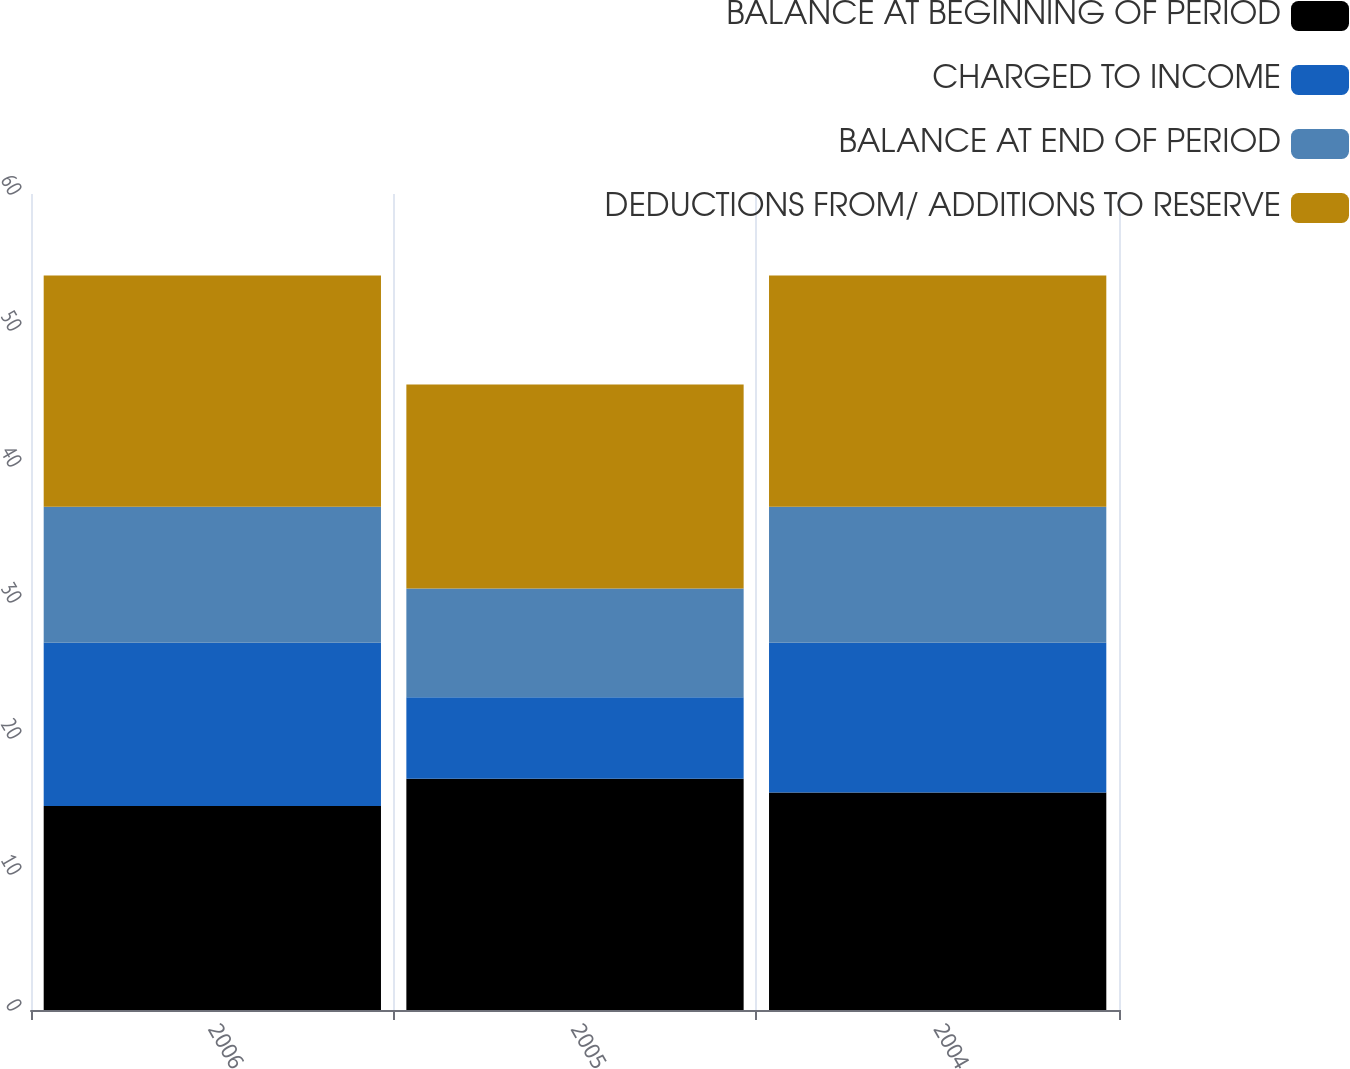Convert chart. <chart><loc_0><loc_0><loc_500><loc_500><stacked_bar_chart><ecel><fcel>2006<fcel>2005<fcel>2004<nl><fcel>BALANCE AT BEGINNING OF PERIOD<fcel>15<fcel>17<fcel>16<nl><fcel>CHARGED TO INCOME<fcel>12<fcel>6<fcel>11<nl><fcel>BALANCE AT END OF PERIOD<fcel>10<fcel>8<fcel>10<nl><fcel>DEDUCTIONS FROM/ ADDITIONS TO RESERVE<fcel>17<fcel>15<fcel>17<nl></chart> 